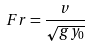Convert formula to latex. <formula><loc_0><loc_0><loc_500><loc_500>F r = \frac { v } { \sqrt { g y _ { 0 } } }</formula> 